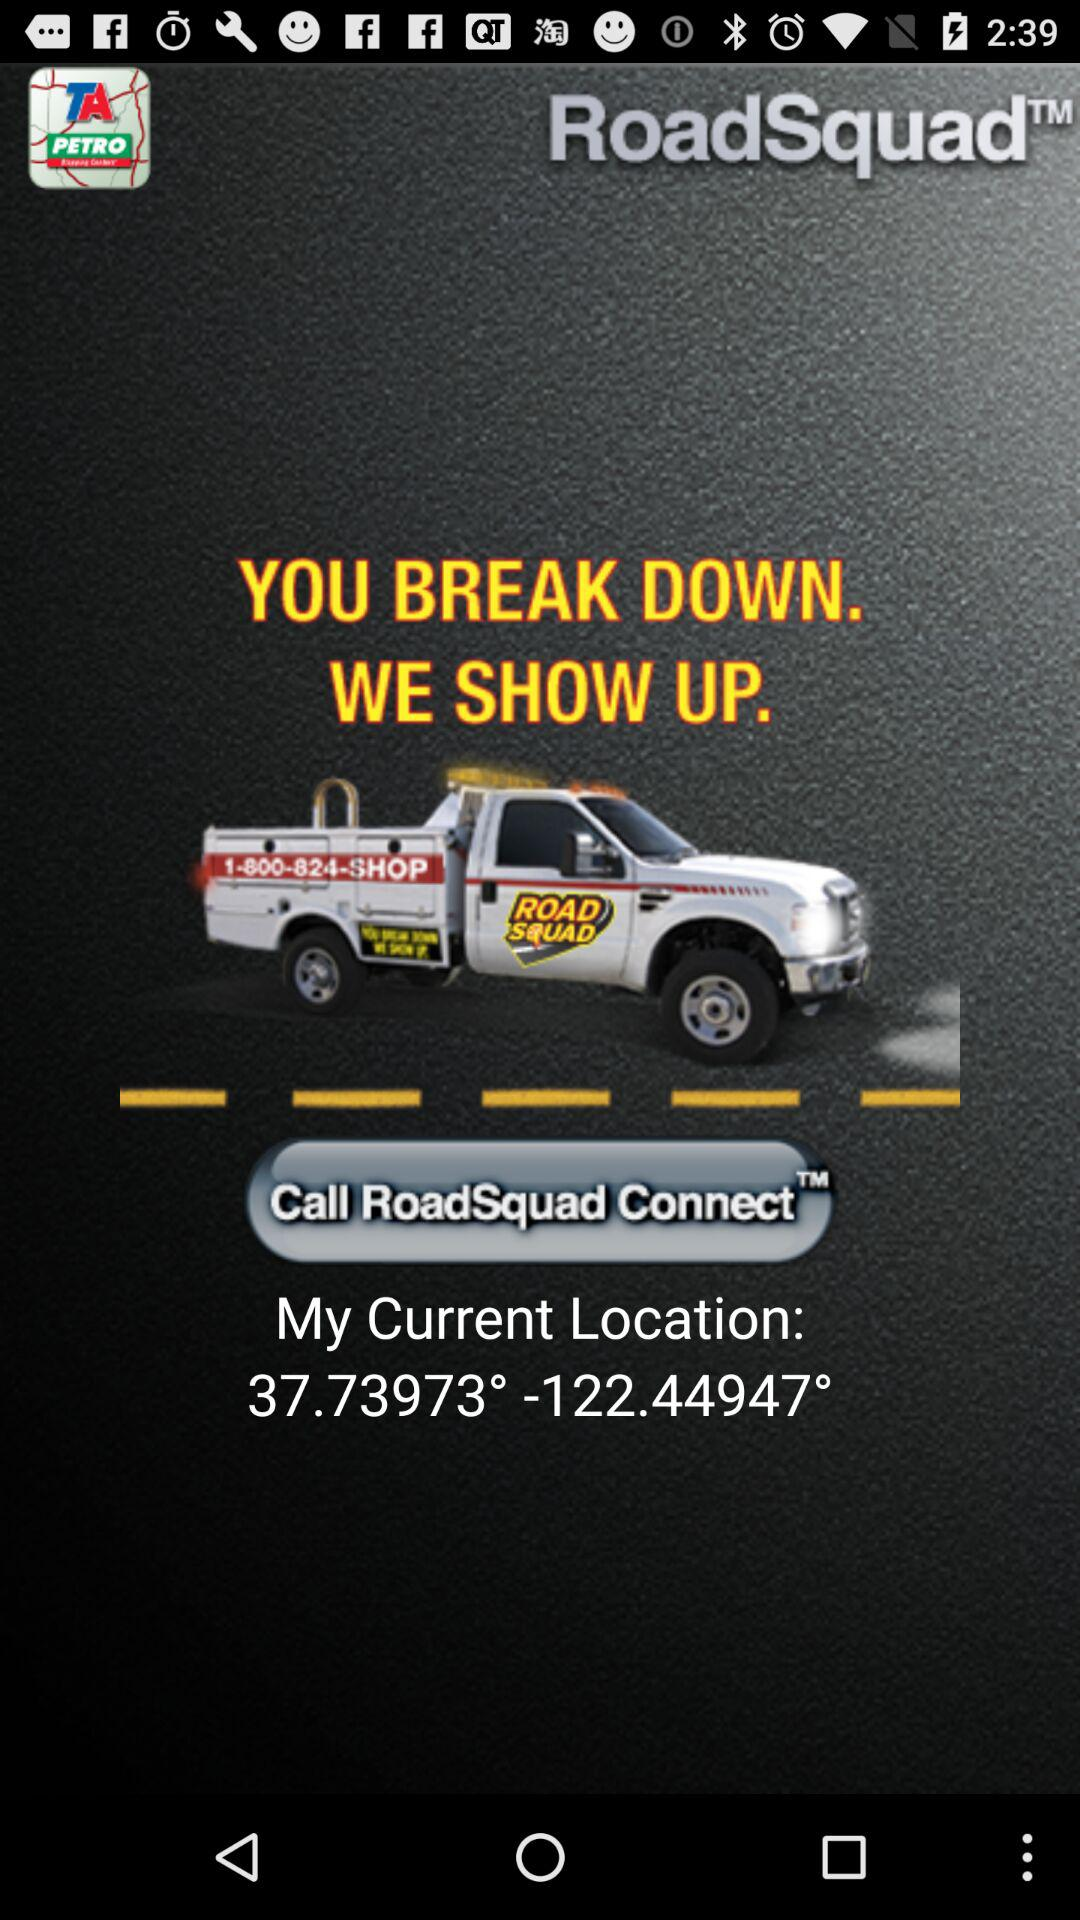How to connect road squad?
When the provided information is insufficient, respond with <no answer>. <no answer> 